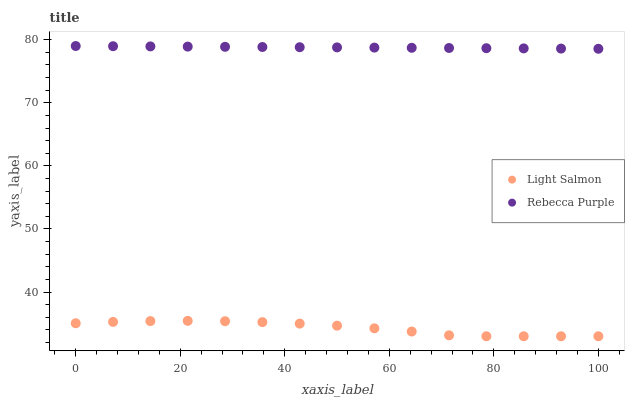Does Light Salmon have the minimum area under the curve?
Answer yes or no. Yes. Does Rebecca Purple have the maximum area under the curve?
Answer yes or no. Yes. Does Rebecca Purple have the minimum area under the curve?
Answer yes or no. No. Is Rebecca Purple the smoothest?
Answer yes or no. Yes. Is Light Salmon the roughest?
Answer yes or no. Yes. Is Rebecca Purple the roughest?
Answer yes or no. No. Does Light Salmon have the lowest value?
Answer yes or no. Yes. Does Rebecca Purple have the lowest value?
Answer yes or no. No. Does Rebecca Purple have the highest value?
Answer yes or no. Yes. Is Light Salmon less than Rebecca Purple?
Answer yes or no. Yes. Is Rebecca Purple greater than Light Salmon?
Answer yes or no. Yes. Does Light Salmon intersect Rebecca Purple?
Answer yes or no. No. 